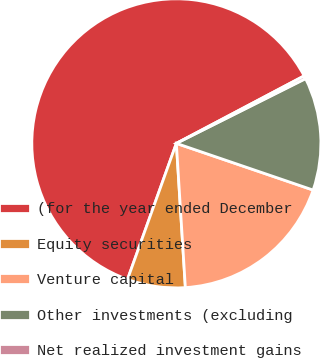Convert chart to OTSL. <chart><loc_0><loc_0><loc_500><loc_500><pie_chart><fcel>(for the year ended December<fcel>Equity securities<fcel>Venture capital<fcel>Other investments (excluding<fcel>Net realized investment gains<nl><fcel>61.78%<fcel>6.48%<fcel>18.77%<fcel>12.63%<fcel>0.34%<nl></chart> 